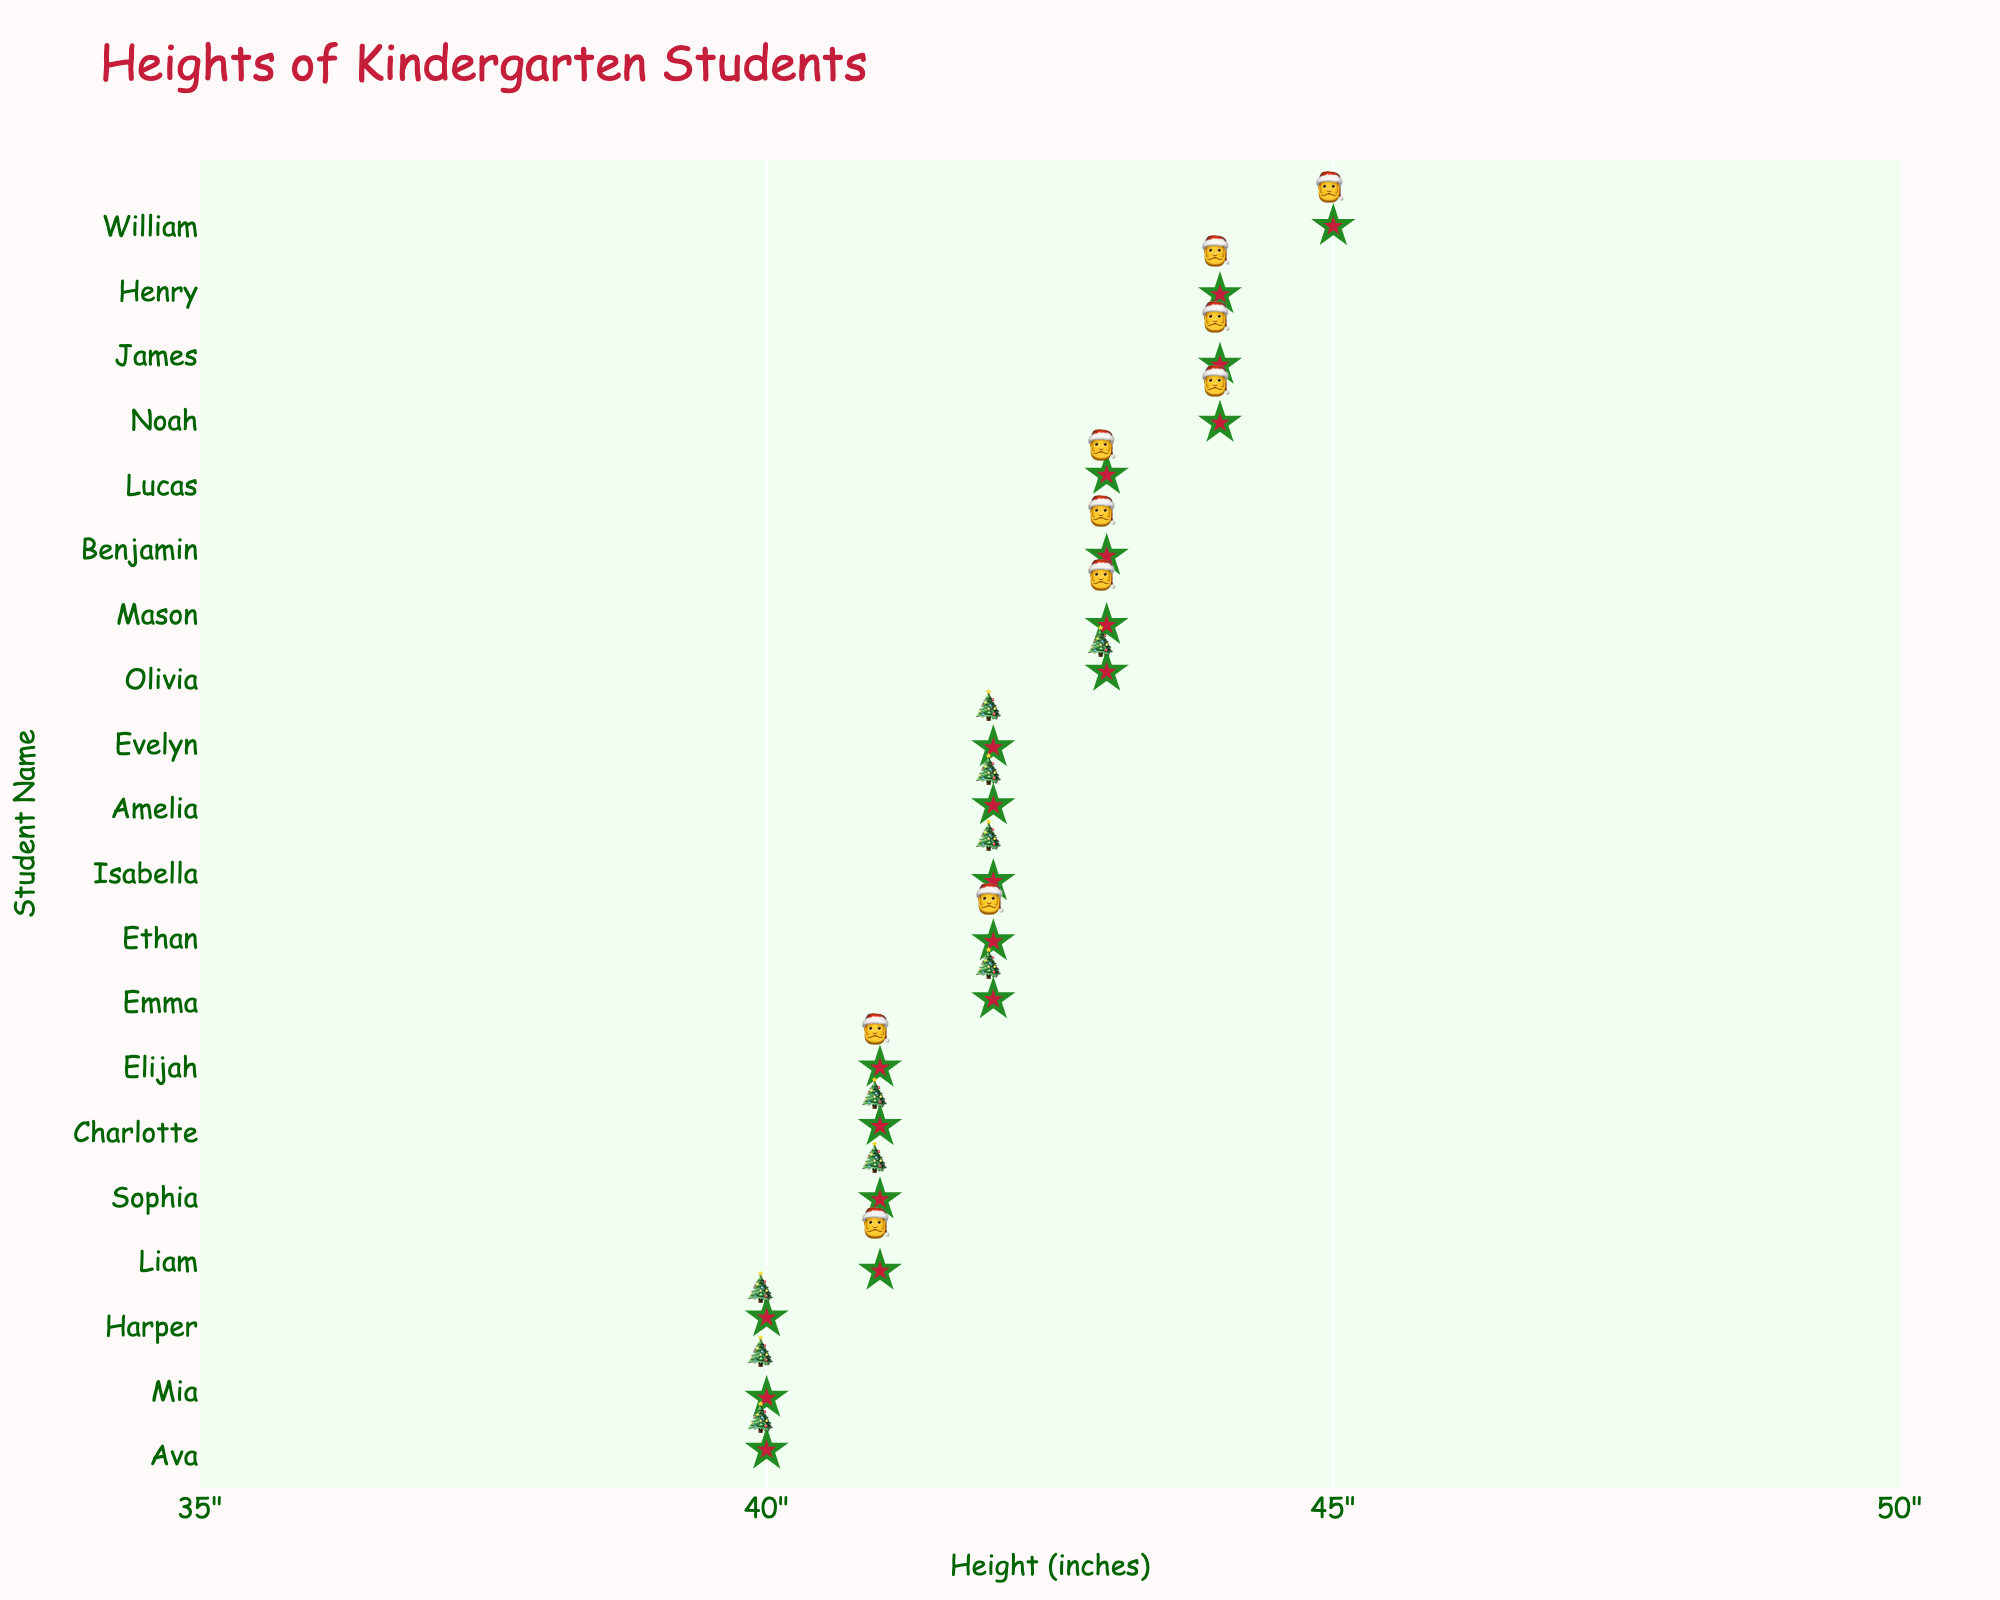what is the title of the figure? At the top of the figure, the title reads "Heights of Kindergarten Students".
Answer: Heights of Kindergarten Students how many students are represented in the plot? Each star represents one student, and there are 20 stars in total.
Answer: 20 which student is the shortest? Look at the leftmost star on the horizontal axis; Ava and Mia are both at 40 inches.
Answer: Ava and Mia what is the range of heights displayed on the x-axis? The x-axis has ticks beginning at 35 inches and ending at 50 inches.
Answer: 35 to 50 inches how many students are exactly 42 inches tall? Count the number of stars at the 42 inches mark. Emma, Ethan, Isabella, Amelia, and Evelyn sum up to 5 students.
Answer: 5 which student is the tallest? Look at the rightmost star on the horizontal axis; William is at 45 inches.
Answer: William how many students are taller than 42 inches? Count stars to the right of the 42 inches mark. There are 8 students: Noah, Mason, William, James, Henry, Lucas, Olivia, and Benjamin.
Answer: 8 what is the average height of the students in the class? Sum the heights (42+41+43+44+40+42+41+43+42+45+40+44+41+43+42+41+40+43+42+44) and divide by the number of students (20). The sum is 853; thus, the average is 853/20 = 42.65 inches.
Answer: 42.65 inches which height has the most students? Look for the height with the most stars. 42 inches has 5 students, the most out of any height.
Answer: 42 inches how many students are exactly 41 inches tall? Count the stars at the 41 inches mark. There are 4 students: Liam, Sophia, Charlotte, and Elijah.
Answer: 4 